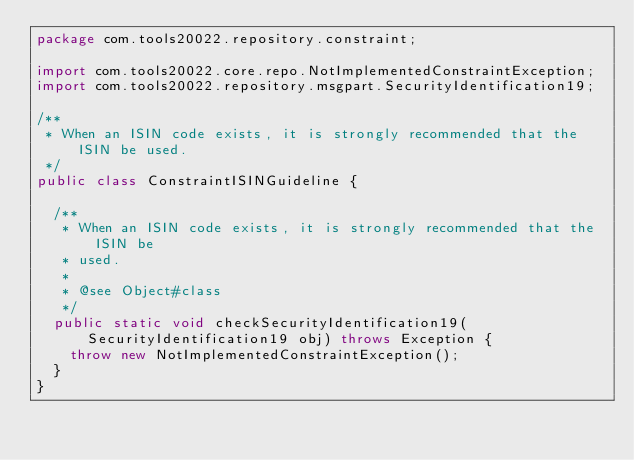Convert code to text. <code><loc_0><loc_0><loc_500><loc_500><_Java_>package com.tools20022.repository.constraint;

import com.tools20022.core.repo.NotImplementedConstraintException;
import com.tools20022.repository.msgpart.SecurityIdentification19;

/**
 * When an ISIN code exists, it is strongly recommended that the ISIN be used.
 */
public class ConstraintISINGuideline {

	/**
	 * When an ISIN code exists, it is strongly recommended that the ISIN be
	 * used.
	 * 
	 * @see Object#class
	 */
	public static void checkSecurityIdentification19(SecurityIdentification19 obj) throws Exception {
		throw new NotImplementedConstraintException();
	}
}</code> 